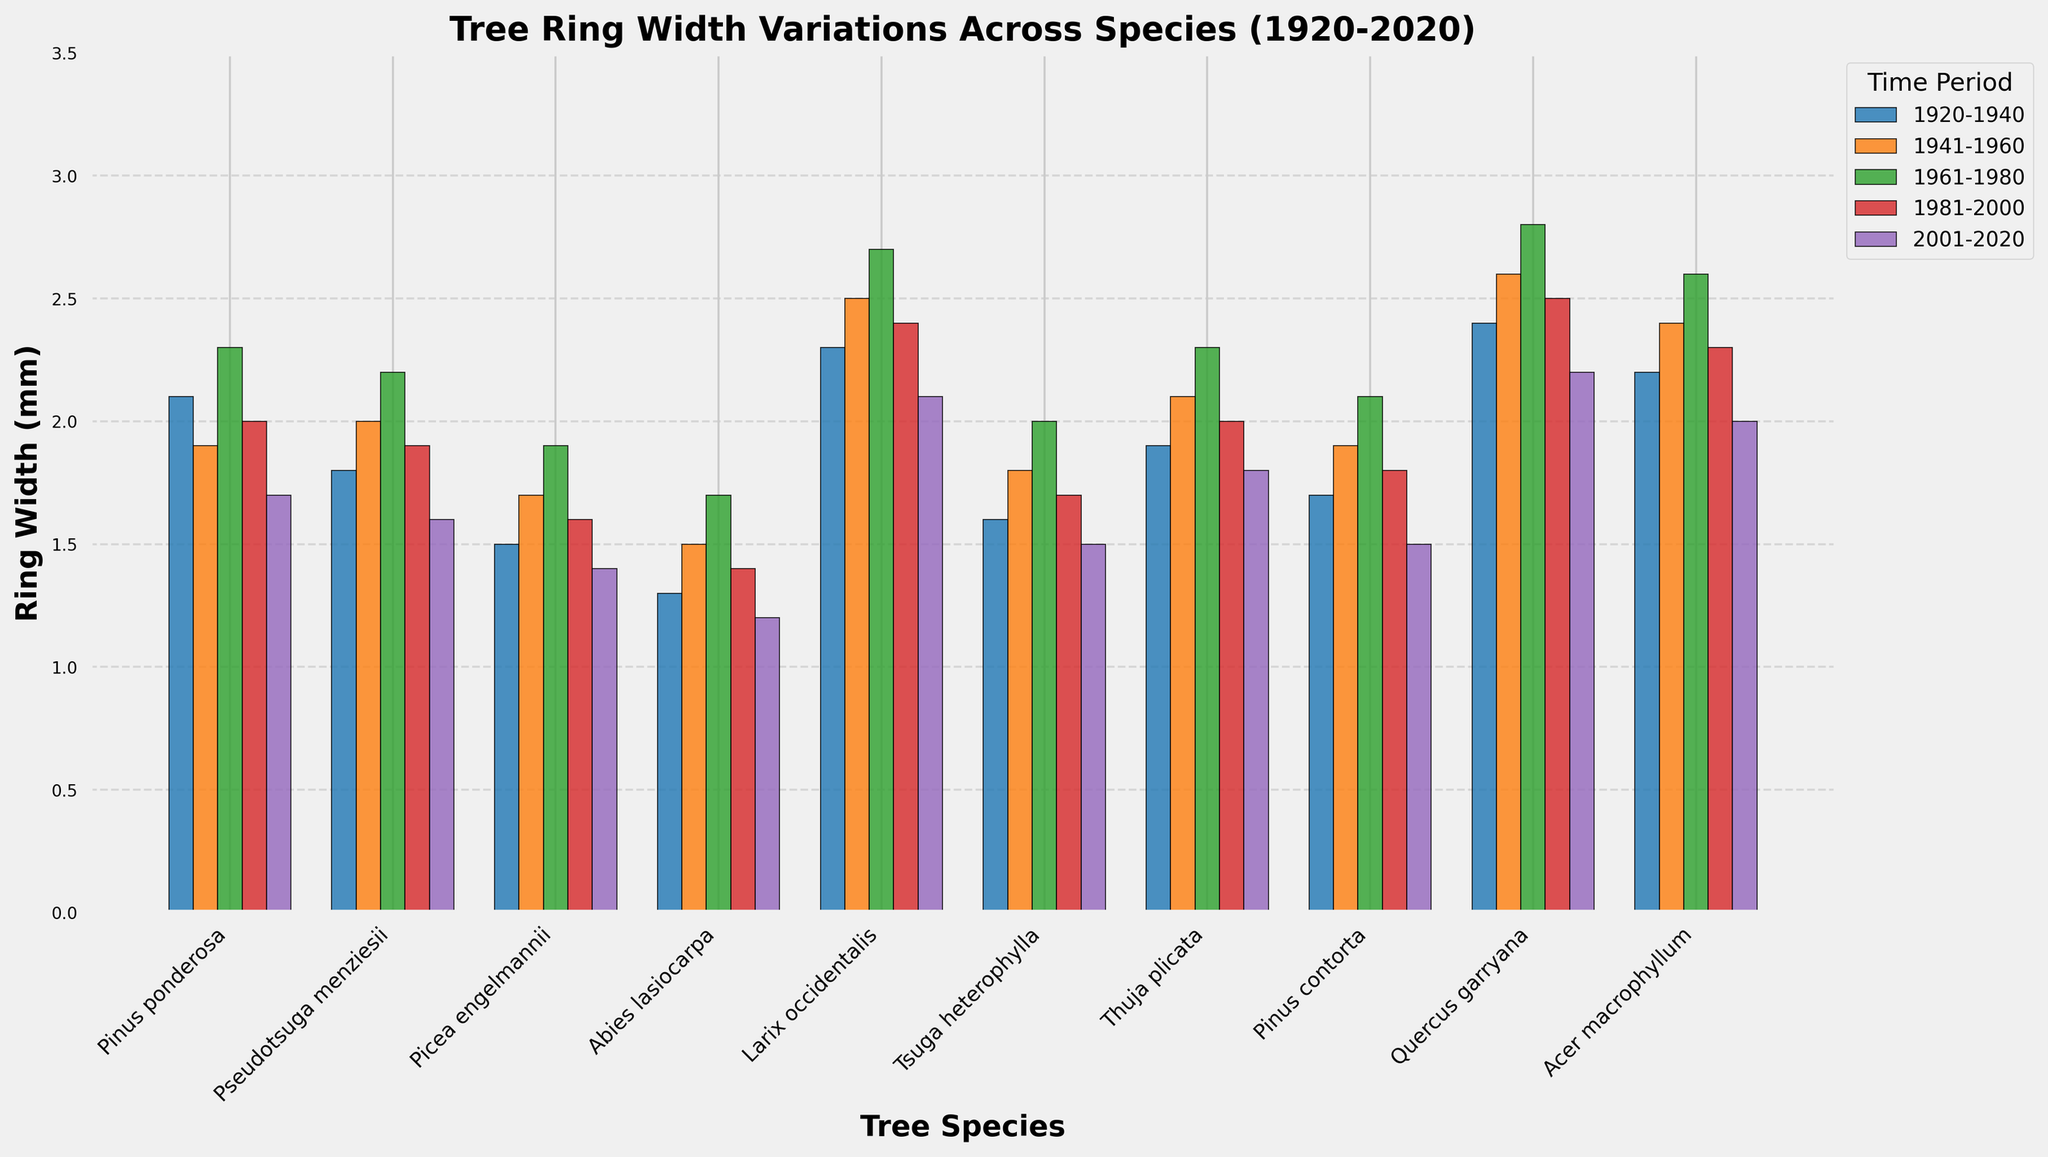Which species had the highest ring width between 1920-1940? Look at the height of the bars for the period 1920-1940. The tallest bar in that period represents Quercus garryana with a ring width of 2.4 mm.
Answer: Quercus garryana Which species experienced the largest decrease in ring width from 1981-2000 to 2001-2020? Subtract the ring width value of 2001-2020 from that of 1981-2000 for each species. The largest decrease is observed in Pseudotsuga menziesii, dropping from 1.9 mm to 1.6 mm, a reduction of 0.3 mm.
Answer: Pseudotsuga menziesii What is the average ring width for Acer macrophyllum across all periods? Sum the ring widths for all periods for Acer macrophyllum and divide by the number of periods: (2.2 + 2.4 + 2.6 + 2.3 + 2.0) / 5. This gives an average of 2.3 mm.
Answer: 2.3 mm How does the 1961-1980 ring width of Tsuga heterophylla compare to the 2001-2020 ring width of the same species? The ring width of Tsuga heterophylla for 1961-1980 is 2.0 mm, while for 2001-2020 it is 1.5 mm. The 1961-1980 period had a higher ring width by 0.5 mm.
Answer: 1961-1980 is higher by 0.5 mm Which period has the shortest ring width for Pinus contorta? Look at the bars representing Pinus contorta across different periods. The shortest bar is for the period 2001-2020, with a ring width of 1.5 mm.
Answer: 2001-2020 If you combine the ring widths of Picea engelmannii and Thuja plicata for 1941-1960, what would be their total? Sum the ring widths for the period 1941-1960 for Picea engelmannii (1.7 mm) and Thuja plicata (2.1 mm), resulting in 3.8 mm.
Answer: 3.8 mm In which period did Larix occidentalis exhibit the highest ring width? Look for the tallest bar representing Larix occidentalis across all periods. The highest ring width is in the period 1961-1980, which is 2.7 mm.
Answer: 1961-1980 What is the difference in ring width between Pinus ponderosa and Abies lasiocarpa for the period 1961-1980? Subtract the ring width of Abies lasiocarpa (1.7 mm) from that of Pinus ponderosa (2.3 mm) for the period 1961-1980, which results in a difference of 0.6 mm.
Answer: 0.6 mm Which species had a consistent decrease in ring width across the periods from 1961-2020? Look for species with decreasing ring widths from 1961-1980, 1981-2000, and 2001-2020. Abies lasiocarpa and Picea engelmannii both show consistent decreases (1.7 to 1.4 to 1.2 for Abies lasiocarpa, and 1.9 to 1.6 to 1.4 for Picea engelmannii).
Answer: Abies lasiocarpa, Picea engelmannii How many species had higher ring widths during 1961-1980 compared to 1941-1960? Compare ring widths for each species between 1961-1980 and 1941-1960. The species with higher ring widths during 1961-1980 are Pinus ponderosa, Pseudotsuga menziesii, Picea engelmannii, Abies lasiocarpa, Larix occidentalis, Tsuga heterophylla, Thuja plicata, Pinus contorta, Quercus garryana, and Acer macrophyllum. All 10 species had higher ring widths.
Answer: 10 species 